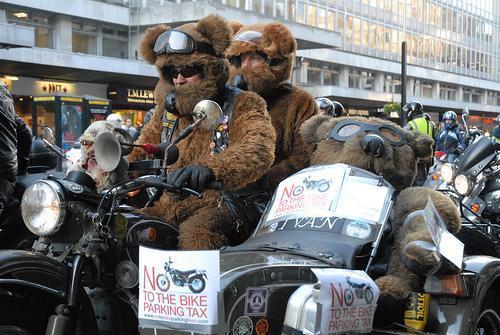How many bears are in the picture?
Give a very brief answer. 3. How many motorcycles are visible?
Give a very brief answer. 3. How many teddy bears are there?
Give a very brief answer. 2. How many people are there?
Give a very brief answer. 3. How many of the birds are sitting?
Give a very brief answer. 0. 